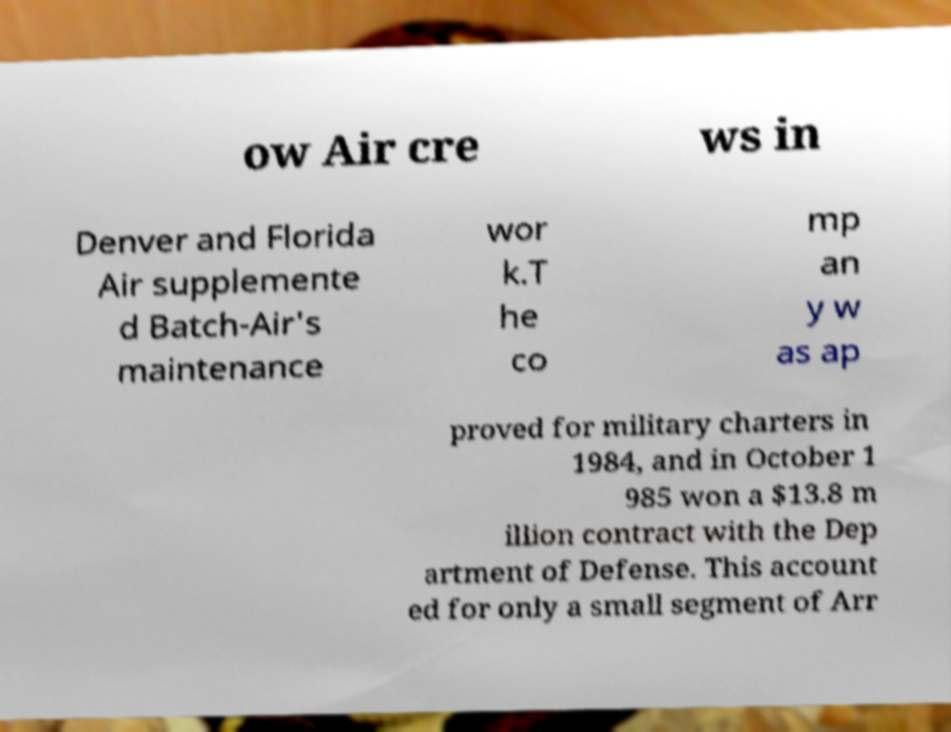Could you assist in decoding the text presented in this image and type it out clearly? ow Air cre ws in Denver and Florida Air supplemente d Batch-Air's maintenance wor k.T he co mp an y w as ap proved for military charters in 1984, and in October 1 985 won a $13.8 m illion contract with the Dep artment of Defense. This account ed for only a small segment of Arr 